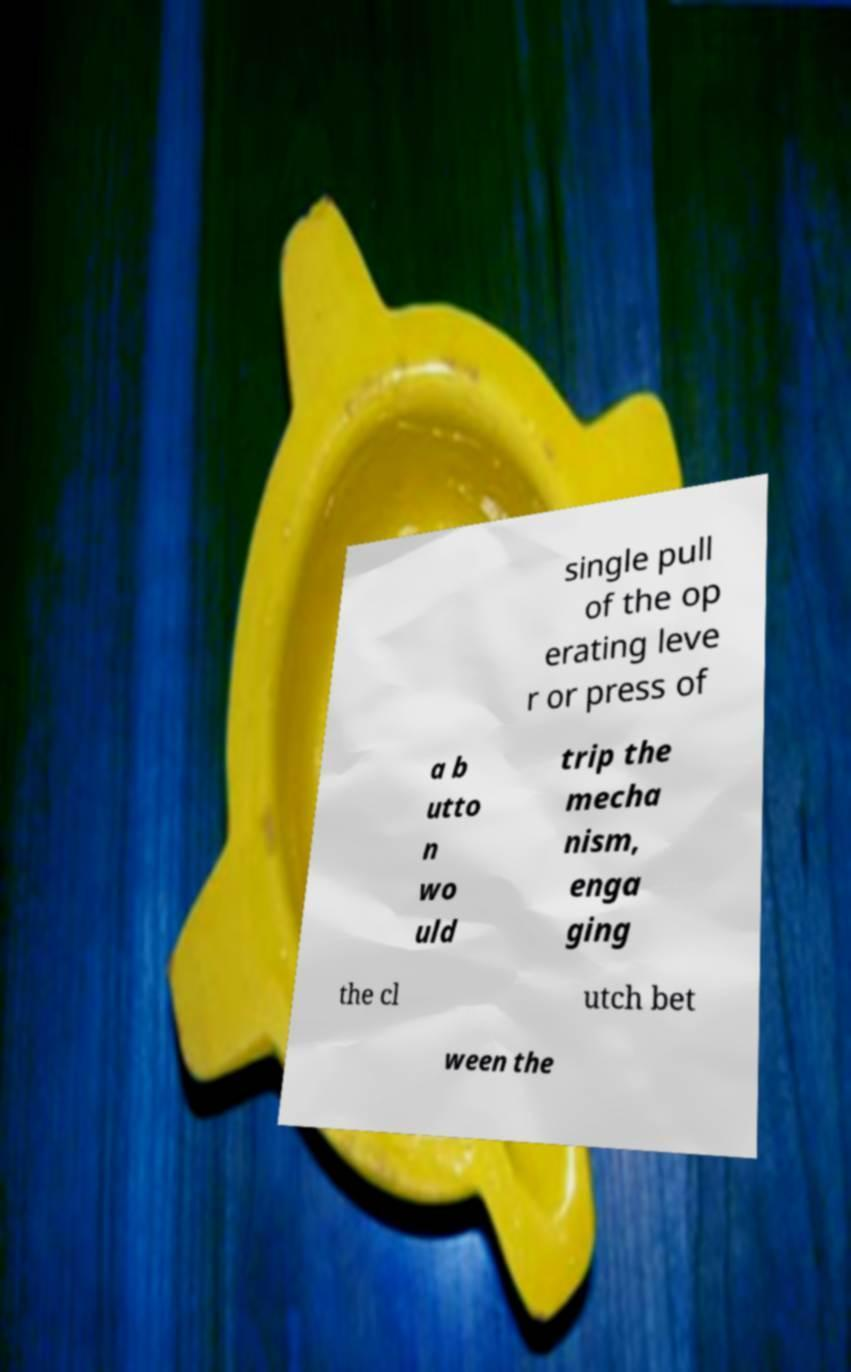Could you extract and type out the text from this image? single pull of the op erating leve r or press of a b utto n wo uld trip the mecha nism, enga ging the cl utch bet ween the 